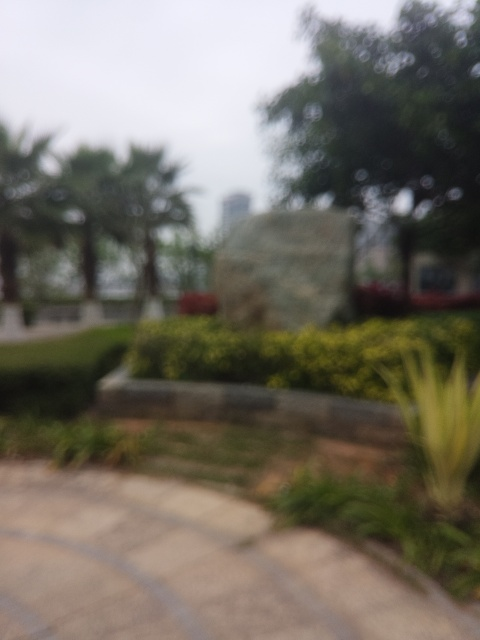What might be the reason for this image being out of focus? There are a few possibilities for why this image is out of focus. It could be the result of a manual focus error, where the camera's focus wasn't adjusted correctly. Alternatively, the camera's autofocus system might have locked onto the wrong subject. Camera shake during exposure or a lens issue could also be culprits. Lastly, it might be an artistic choice, aiming to create an abstract or dreamy visual effect. 